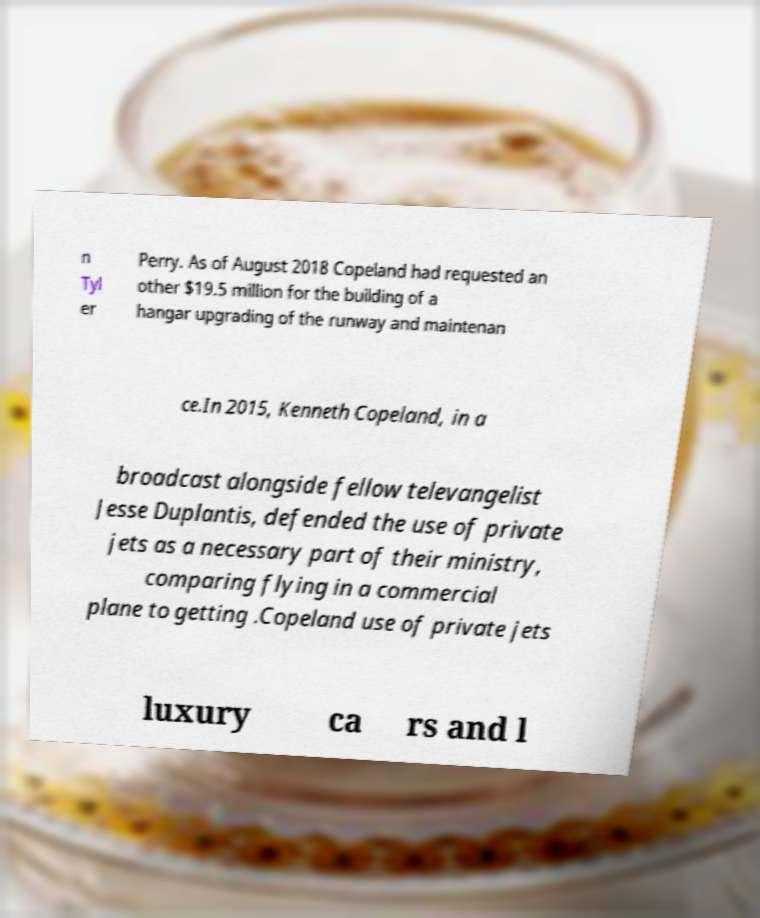Please identify and transcribe the text found in this image. n Tyl er Perry. As of August 2018 Copeland had requested an other $19.5 million for the building of a hangar upgrading of the runway and maintenan ce.In 2015, Kenneth Copeland, in a broadcast alongside fellow televangelist Jesse Duplantis, defended the use of private jets as a necessary part of their ministry, comparing flying in a commercial plane to getting .Copeland use of private jets luxury ca rs and l 